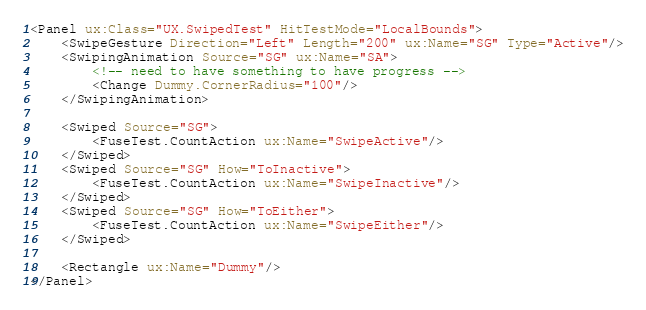Convert code to text. <code><loc_0><loc_0><loc_500><loc_500><_XML_><Panel ux:Class="UX.SwipedTest" HitTestMode="LocalBounds">
	<SwipeGesture Direction="Left" Length="200" ux:Name="SG" Type="Active"/>
	<SwipingAnimation Source="SG" ux:Name="SA">
		<!-- need to have something to have progress -->
		<Change Dummy.CornerRadius="100"/>
	</SwipingAnimation>

	<Swiped Source="SG">
		<FuseTest.CountAction ux:Name="SwipeActive"/>
	</Swiped>
	<Swiped Source="SG" How="ToInactive">
		<FuseTest.CountAction ux:Name="SwipeInactive"/>
	</Swiped>
	<Swiped Source="SG" How="ToEither">
		<FuseTest.CountAction ux:Name="SwipeEither"/>
	</Swiped>

	<Rectangle ux:Name="Dummy"/>
</Panel></code> 